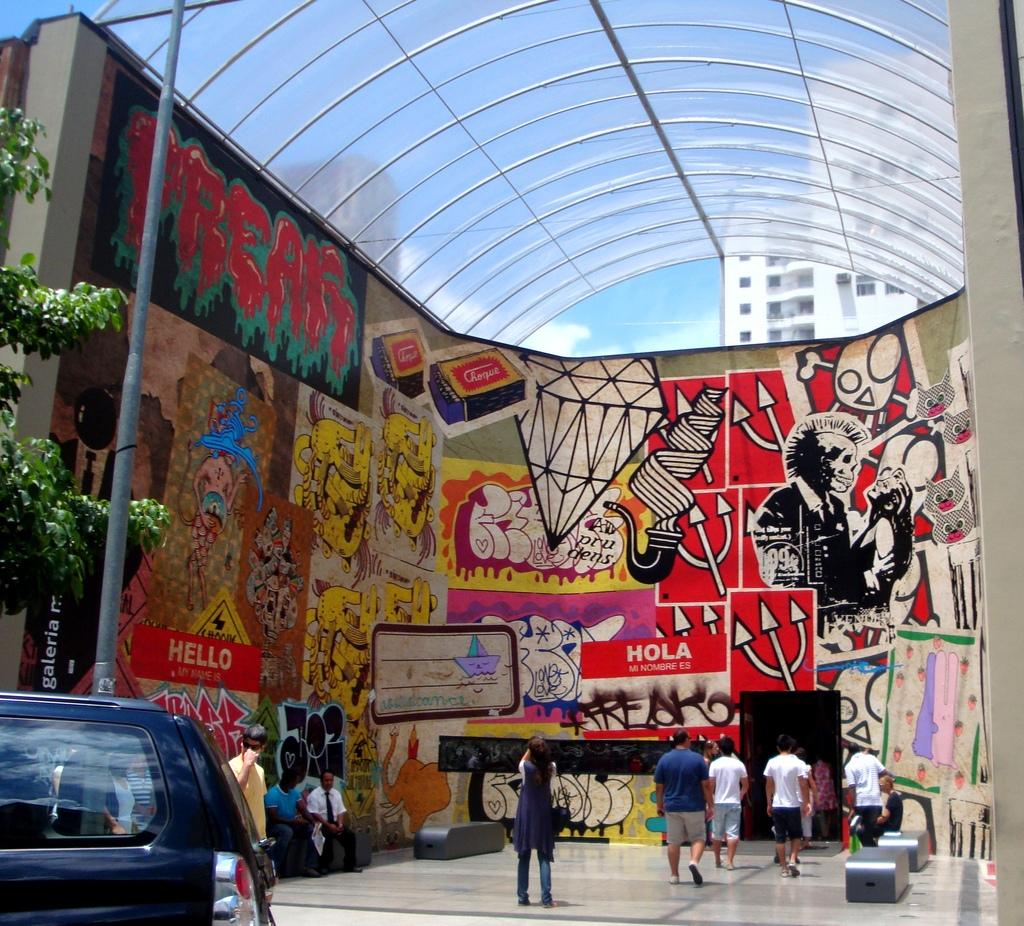<image>
Summarize the visual content of the image. An arcade with posters and graffiti including one that says HOLA MI NOMBRE ES. 